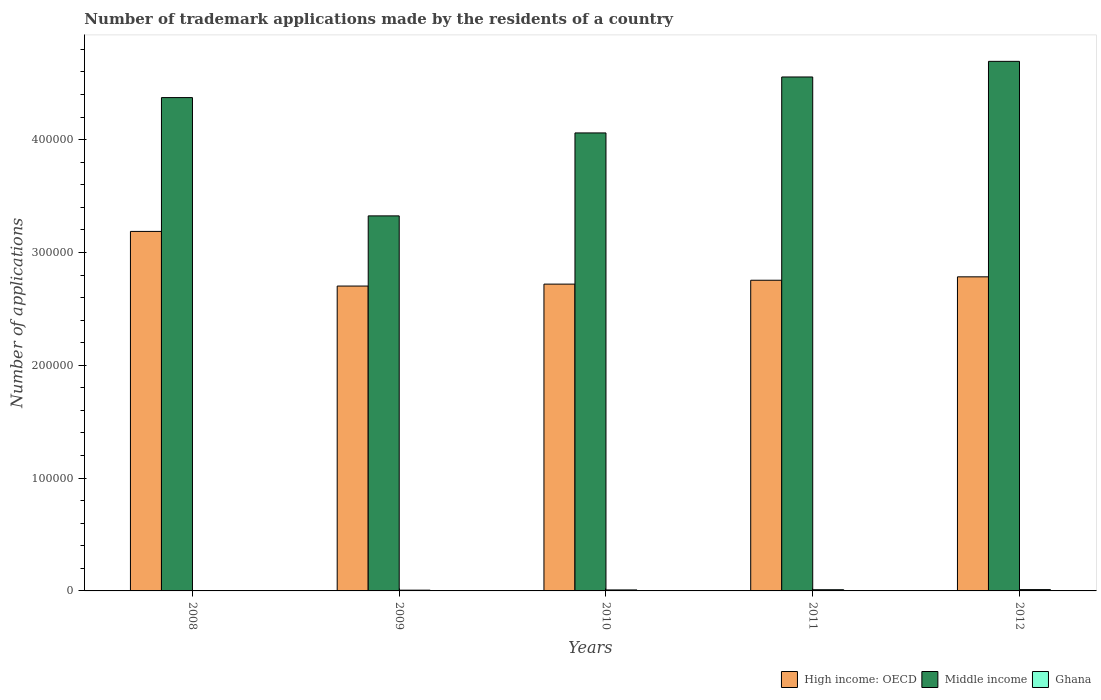How many groups of bars are there?
Your answer should be very brief. 5. Are the number of bars on each tick of the X-axis equal?
Make the answer very short. Yes. How many bars are there on the 3rd tick from the left?
Give a very brief answer. 3. What is the label of the 1st group of bars from the left?
Keep it short and to the point. 2008. In how many cases, is the number of bars for a given year not equal to the number of legend labels?
Your answer should be compact. 0. What is the number of trademark applications made by the residents in Ghana in 2011?
Your answer should be compact. 1067. Across all years, what is the maximum number of trademark applications made by the residents in High income: OECD?
Your response must be concise. 3.19e+05. Across all years, what is the minimum number of trademark applications made by the residents in Middle income?
Your response must be concise. 3.32e+05. In which year was the number of trademark applications made by the residents in Ghana maximum?
Give a very brief answer. 2012. What is the total number of trademark applications made by the residents in Middle income in the graph?
Make the answer very short. 2.10e+06. What is the difference between the number of trademark applications made by the residents in Ghana in 2009 and that in 2010?
Your response must be concise. -205. What is the difference between the number of trademark applications made by the residents in Middle income in 2008 and the number of trademark applications made by the residents in Ghana in 2009?
Offer a terse response. 4.37e+05. What is the average number of trademark applications made by the residents in High income: OECD per year?
Your answer should be compact. 2.83e+05. In the year 2008, what is the difference between the number of trademark applications made by the residents in Ghana and number of trademark applications made by the residents in Middle income?
Ensure brevity in your answer.  -4.37e+05. What is the ratio of the number of trademark applications made by the residents in Ghana in 2009 to that in 2012?
Offer a very short reply. 0.58. Is the number of trademark applications made by the residents in High income: OECD in 2009 less than that in 2011?
Your answer should be very brief. Yes. What is the difference between the highest and the second highest number of trademark applications made by the residents in High income: OECD?
Your answer should be compact. 4.03e+04. What is the difference between the highest and the lowest number of trademark applications made by the residents in High income: OECD?
Provide a short and direct response. 4.84e+04. Is the sum of the number of trademark applications made by the residents in Middle income in 2008 and 2010 greater than the maximum number of trademark applications made by the residents in Ghana across all years?
Provide a succinct answer. Yes. What does the 3rd bar from the left in 2012 represents?
Provide a short and direct response. Ghana. Are all the bars in the graph horizontal?
Your answer should be very brief. No. How many years are there in the graph?
Provide a succinct answer. 5. Does the graph contain any zero values?
Provide a short and direct response. No. Does the graph contain grids?
Your response must be concise. No. How many legend labels are there?
Offer a terse response. 3. How are the legend labels stacked?
Offer a terse response. Horizontal. What is the title of the graph?
Offer a terse response. Number of trademark applications made by the residents of a country. Does "El Salvador" appear as one of the legend labels in the graph?
Your response must be concise. No. What is the label or title of the Y-axis?
Give a very brief answer. Number of applications. What is the Number of applications in High income: OECD in 2008?
Keep it short and to the point. 3.19e+05. What is the Number of applications in Middle income in 2008?
Your answer should be compact. 4.37e+05. What is the Number of applications of Ghana in 2008?
Your answer should be very brief. 61. What is the Number of applications in High income: OECD in 2009?
Your answer should be very brief. 2.70e+05. What is the Number of applications of Middle income in 2009?
Offer a terse response. 3.32e+05. What is the Number of applications in Ghana in 2009?
Give a very brief answer. 677. What is the Number of applications in High income: OECD in 2010?
Your response must be concise. 2.72e+05. What is the Number of applications of Middle income in 2010?
Ensure brevity in your answer.  4.06e+05. What is the Number of applications in Ghana in 2010?
Your response must be concise. 882. What is the Number of applications in High income: OECD in 2011?
Offer a terse response. 2.75e+05. What is the Number of applications of Middle income in 2011?
Your answer should be very brief. 4.56e+05. What is the Number of applications in Ghana in 2011?
Your answer should be very brief. 1067. What is the Number of applications in High income: OECD in 2012?
Give a very brief answer. 2.78e+05. What is the Number of applications of Middle income in 2012?
Provide a succinct answer. 4.69e+05. What is the Number of applications of Ghana in 2012?
Offer a terse response. 1177. Across all years, what is the maximum Number of applications in High income: OECD?
Give a very brief answer. 3.19e+05. Across all years, what is the maximum Number of applications of Middle income?
Your response must be concise. 4.69e+05. Across all years, what is the maximum Number of applications of Ghana?
Offer a terse response. 1177. Across all years, what is the minimum Number of applications in High income: OECD?
Ensure brevity in your answer.  2.70e+05. Across all years, what is the minimum Number of applications in Middle income?
Offer a very short reply. 3.32e+05. Across all years, what is the minimum Number of applications of Ghana?
Make the answer very short. 61. What is the total Number of applications in High income: OECD in the graph?
Make the answer very short. 1.41e+06. What is the total Number of applications of Middle income in the graph?
Make the answer very short. 2.10e+06. What is the total Number of applications in Ghana in the graph?
Give a very brief answer. 3864. What is the difference between the Number of applications in High income: OECD in 2008 and that in 2009?
Make the answer very short. 4.84e+04. What is the difference between the Number of applications in Middle income in 2008 and that in 2009?
Your answer should be very brief. 1.05e+05. What is the difference between the Number of applications in Ghana in 2008 and that in 2009?
Make the answer very short. -616. What is the difference between the Number of applications of High income: OECD in 2008 and that in 2010?
Ensure brevity in your answer.  4.67e+04. What is the difference between the Number of applications in Middle income in 2008 and that in 2010?
Provide a short and direct response. 3.13e+04. What is the difference between the Number of applications in Ghana in 2008 and that in 2010?
Give a very brief answer. -821. What is the difference between the Number of applications of High income: OECD in 2008 and that in 2011?
Ensure brevity in your answer.  4.33e+04. What is the difference between the Number of applications of Middle income in 2008 and that in 2011?
Your response must be concise. -1.83e+04. What is the difference between the Number of applications of Ghana in 2008 and that in 2011?
Your answer should be very brief. -1006. What is the difference between the Number of applications of High income: OECD in 2008 and that in 2012?
Provide a short and direct response. 4.03e+04. What is the difference between the Number of applications of Middle income in 2008 and that in 2012?
Your answer should be compact. -3.21e+04. What is the difference between the Number of applications of Ghana in 2008 and that in 2012?
Give a very brief answer. -1116. What is the difference between the Number of applications of High income: OECD in 2009 and that in 2010?
Provide a succinct answer. -1716. What is the difference between the Number of applications of Middle income in 2009 and that in 2010?
Make the answer very short. -7.35e+04. What is the difference between the Number of applications in Ghana in 2009 and that in 2010?
Offer a very short reply. -205. What is the difference between the Number of applications of High income: OECD in 2009 and that in 2011?
Make the answer very short. -5155. What is the difference between the Number of applications of Middle income in 2009 and that in 2011?
Provide a short and direct response. -1.23e+05. What is the difference between the Number of applications of Ghana in 2009 and that in 2011?
Offer a very short reply. -390. What is the difference between the Number of applications in High income: OECD in 2009 and that in 2012?
Give a very brief answer. -8171. What is the difference between the Number of applications of Middle income in 2009 and that in 2012?
Your response must be concise. -1.37e+05. What is the difference between the Number of applications of Ghana in 2009 and that in 2012?
Your answer should be very brief. -500. What is the difference between the Number of applications of High income: OECD in 2010 and that in 2011?
Offer a terse response. -3439. What is the difference between the Number of applications of Middle income in 2010 and that in 2011?
Ensure brevity in your answer.  -4.96e+04. What is the difference between the Number of applications in Ghana in 2010 and that in 2011?
Offer a very short reply. -185. What is the difference between the Number of applications in High income: OECD in 2010 and that in 2012?
Your answer should be very brief. -6455. What is the difference between the Number of applications in Middle income in 2010 and that in 2012?
Your answer should be very brief. -6.34e+04. What is the difference between the Number of applications of Ghana in 2010 and that in 2012?
Offer a terse response. -295. What is the difference between the Number of applications in High income: OECD in 2011 and that in 2012?
Provide a short and direct response. -3016. What is the difference between the Number of applications in Middle income in 2011 and that in 2012?
Provide a succinct answer. -1.38e+04. What is the difference between the Number of applications in Ghana in 2011 and that in 2012?
Provide a short and direct response. -110. What is the difference between the Number of applications of High income: OECD in 2008 and the Number of applications of Middle income in 2009?
Offer a terse response. -1.38e+04. What is the difference between the Number of applications in High income: OECD in 2008 and the Number of applications in Ghana in 2009?
Provide a short and direct response. 3.18e+05. What is the difference between the Number of applications of Middle income in 2008 and the Number of applications of Ghana in 2009?
Provide a succinct answer. 4.37e+05. What is the difference between the Number of applications in High income: OECD in 2008 and the Number of applications in Middle income in 2010?
Keep it short and to the point. -8.73e+04. What is the difference between the Number of applications in High income: OECD in 2008 and the Number of applications in Ghana in 2010?
Keep it short and to the point. 3.18e+05. What is the difference between the Number of applications of Middle income in 2008 and the Number of applications of Ghana in 2010?
Keep it short and to the point. 4.36e+05. What is the difference between the Number of applications in High income: OECD in 2008 and the Number of applications in Middle income in 2011?
Provide a short and direct response. -1.37e+05. What is the difference between the Number of applications of High income: OECD in 2008 and the Number of applications of Ghana in 2011?
Provide a short and direct response. 3.18e+05. What is the difference between the Number of applications in Middle income in 2008 and the Number of applications in Ghana in 2011?
Make the answer very short. 4.36e+05. What is the difference between the Number of applications in High income: OECD in 2008 and the Number of applications in Middle income in 2012?
Your answer should be compact. -1.51e+05. What is the difference between the Number of applications of High income: OECD in 2008 and the Number of applications of Ghana in 2012?
Make the answer very short. 3.17e+05. What is the difference between the Number of applications of Middle income in 2008 and the Number of applications of Ghana in 2012?
Keep it short and to the point. 4.36e+05. What is the difference between the Number of applications in High income: OECD in 2009 and the Number of applications in Middle income in 2010?
Offer a terse response. -1.36e+05. What is the difference between the Number of applications of High income: OECD in 2009 and the Number of applications of Ghana in 2010?
Keep it short and to the point. 2.69e+05. What is the difference between the Number of applications in Middle income in 2009 and the Number of applications in Ghana in 2010?
Provide a succinct answer. 3.32e+05. What is the difference between the Number of applications of High income: OECD in 2009 and the Number of applications of Middle income in 2011?
Offer a very short reply. -1.85e+05. What is the difference between the Number of applications of High income: OECD in 2009 and the Number of applications of Ghana in 2011?
Ensure brevity in your answer.  2.69e+05. What is the difference between the Number of applications of Middle income in 2009 and the Number of applications of Ghana in 2011?
Make the answer very short. 3.31e+05. What is the difference between the Number of applications of High income: OECD in 2009 and the Number of applications of Middle income in 2012?
Offer a very short reply. -1.99e+05. What is the difference between the Number of applications in High income: OECD in 2009 and the Number of applications in Ghana in 2012?
Make the answer very short. 2.69e+05. What is the difference between the Number of applications of Middle income in 2009 and the Number of applications of Ghana in 2012?
Provide a succinct answer. 3.31e+05. What is the difference between the Number of applications in High income: OECD in 2010 and the Number of applications in Middle income in 2011?
Give a very brief answer. -1.84e+05. What is the difference between the Number of applications of High income: OECD in 2010 and the Number of applications of Ghana in 2011?
Provide a short and direct response. 2.71e+05. What is the difference between the Number of applications of Middle income in 2010 and the Number of applications of Ghana in 2011?
Give a very brief answer. 4.05e+05. What is the difference between the Number of applications of High income: OECD in 2010 and the Number of applications of Middle income in 2012?
Provide a succinct answer. -1.97e+05. What is the difference between the Number of applications of High income: OECD in 2010 and the Number of applications of Ghana in 2012?
Your answer should be very brief. 2.71e+05. What is the difference between the Number of applications of Middle income in 2010 and the Number of applications of Ghana in 2012?
Ensure brevity in your answer.  4.05e+05. What is the difference between the Number of applications in High income: OECD in 2011 and the Number of applications in Middle income in 2012?
Give a very brief answer. -1.94e+05. What is the difference between the Number of applications in High income: OECD in 2011 and the Number of applications in Ghana in 2012?
Offer a very short reply. 2.74e+05. What is the difference between the Number of applications of Middle income in 2011 and the Number of applications of Ghana in 2012?
Offer a very short reply. 4.54e+05. What is the average Number of applications in High income: OECD per year?
Provide a succinct answer. 2.83e+05. What is the average Number of applications of Middle income per year?
Offer a very short reply. 4.20e+05. What is the average Number of applications of Ghana per year?
Your answer should be very brief. 772.8. In the year 2008, what is the difference between the Number of applications in High income: OECD and Number of applications in Middle income?
Your answer should be very brief. -1.19e+05. In the year 2008, what is the difference between the Number of applications of High income: OECD and Number of applications of Ghana?
Provide a short and direct response. 3.19e+05. In the year 2008, what is the difference between the Number of applications in Middle income and Number of applications in Ghana?
Provide a short and direct response. 4.37e+05. In the year 2009, what is the difference between the Number of applications of High income: OECD and Number of applications of Middle income?
Offer a terse response. -6.22e+04. In the year 2009, what is the difference between the Number of applications in High income: OECD and Number of applications in Ghana?
Offer a terse response. 2.70e+05. In the year 2009, what is the difference between the Number of applications in Middle income and Number of applications in Ghana?
Keep it short and to the point. 3.32e+05. In the year 2010, what is the difference between the Number of applications in High income: OECD and Number of applications in Middle income?
Offer a terse response. -1.34e+05. In the year 2010, what is the difference between the Number of applications of High income: OECD and Number of applications of Ghana?
Make the answer very short. 2.71e+05. In the year 2010, what is the difference between the Number of applications of Middle income and Number of applications of Ghana?
Offer a terse response. 4.05e+05. In the year 2011, what is the difference between the Number of applications of High income: OECD and Number of applications of Middle income?
Your answer should be compact. -1.80e+05. In the year 2011, what is the difference between the Number of applications of High income: OECD and Number of applications of Ghana?
Keep it short and to the point. 2.74e+05. In the year 2011, what is the difference between the Number of applications of Middle income and Number of applications of Ghana?
Make the answer very short. 4.54e+05. In the year 2012, what is the difference between the Number of applications in High income: OECD and Number of applications in Middle income?
Ensure brevity in your answer.  -1.91e+05. In the year 2012, what is the difference between the Number of applications in High income: OECD and Number of applications in Ghana?
Your response must be concise. 2.77e+05. In the year 2012, what is the difference between the Number of applications of Middle income and Number of applications of Ghana?
Offer a very short reply. 4.68e+05. What is the ratio of the Number of applications in High income: OECD in 2008 to that in 2009?
Give a very brief answer. 1.18. What is the ratio of the Number of applications in Middle income in 2008 to that in 2009?
Give a very brief answer. 1.32. What is the ratio of the Number of applications in Ghana in 2008 to that in 2009?
Make the answer very short. 0.09. What is the ratio of the Number of applications of High income: OECD in 2008 to that in 2010?
Keep it short and to the point. 1.17. What is the ratio of the Number of applications of Middle income in 2008 to that in 2010?
Give a very brief answer. 1.08. What is the ratio of the Number of applications in Ghana in 2008 to that in 2010?
Your answer should be compact. 0.07. What is the ratio of the Number of applications of High income: OECD in 2008 to that in 2011?
Keep it short and to the point. 1.16. What is the ratio of the Number of applications in Middle income in 2008 to that in 2011?
Your answer should be very brief. 0.96. What is the ratio of the Number of applications in Ghana in 2008 to that in 2011?
Ensure brevity in your answer.  0.06. What is the ratio of the Number of applications in High income: OECD in 2008 to that in 2012?
Your response must be concise. 1.14. What is the ratio of the Number of applications of Middle income in 2008 to that in 2012?
Make the answer very short. 0.93. What is the ratio of the Number of applications of Ghana in 2008 to that in 2012?
Provide a short and direct response. 0.05. What is the ratio of the Number of applications of Middle income in 2009 to that in 2010?
Your answer should be compact. 0.82. What is the ratio of the Number of applications of Ghana in 2009 to that in 2010?
Your answer should be very brief. 0.77. What is the ratio of the Number of applications in High income: OECD in 2009 to that in 2011?
Ensure brevity in your answer.  0.98. What is the ratio of the Number of applications of Middle income in 2009 to that in 2011?
Offer a terse response. 0.73. What is the ratio of the Number of applications in Ghana in 2009 to that in 2011?
Ensure brevity in your answer.  0.63. What is the ratio of the Number of applications of High income: OECD in 2009 to that in 2012?
Offer a very short reply. 0.97. What is the ratio of the Number of applications of Middle income in 2009 to that in 2012?
Offer a very short reply. 0.71. What is the ratio of the Number of applications of Ghana in 2009 to that in 2012?
Offer a terse response. 0.58. What is the ratio of the Number of applications of High income: OECD in 2010 to that in 2011?
Give a very brief answer. 0.99. What is the ratio of the Number of applications of Middle income in 2010 to that in 2011?
Provide a succinct answer. 0.89. What is the ratio of the Number of applications of Ghana in 2010 to that in 2011?
Provide a succinct answer. 0.83. What is the ratio of the Number of applications of High income: OECD in 2010 to that in 2012?
Keep it short and to the point. 0.98. What is the ratio of the Number of applications in Middle income in 2010 to that in 2012?
Make the answer very short. 0.86. What is the ratio of the Number of applications of Ghana in 2010 to that in 2012?
Offer a terse response. 0.75. What is the ratio of the Number of applications in High income: OECD in 2011 to that in 2012?
Offer a very short reply. 0.99. What is the ratio of the Number of applications in Middle income in 2011 to that in 2012?
Your answer should be very brief. 0.97. What is the ratio of the Number of applications of Ghana in 2011 to that in 2012?
Your response must be concise. 0.91. What is the difference between the highest and the second highest Number of applications in High income: OECD?
Offer a terse response. 4.03e+04. What is the difference between the highest and the second highest Number of applications in Middle income?
Keep it short and to the point. 1.38e+04. What is the difference between the highest and the second highest Number of applications of Ghana?
Give a very brief answer. 110. What is the difference between the highest and the lowest Number of applications of High income: OECD?
Provide a short and direct response. 4.84e+04. What is the difference between the highest and the lowest Number of applications of Middle income?
Your response must be concise. 1.37e+05. What is the difference between the highest and the lowest Number of applications in Ghana?
Make the answer very short. 1116. 